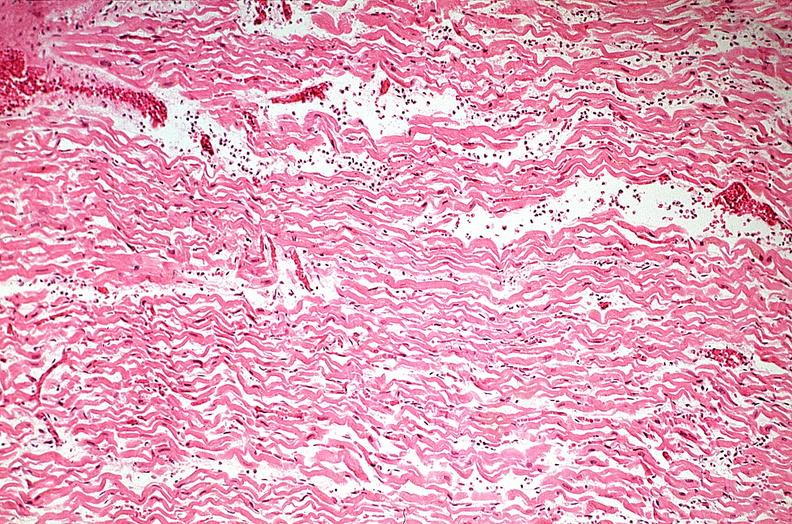s cardiovascular present?
Answer the question using a single word or phrase. Yes 